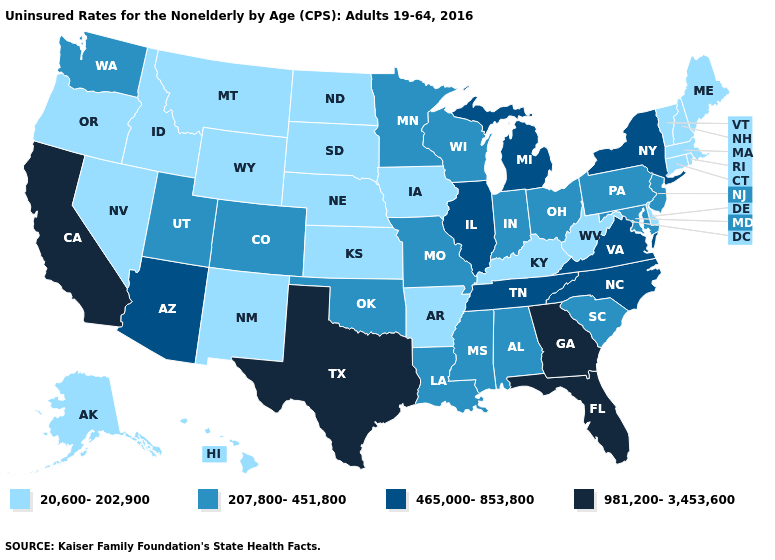Name the states that have a value in the range 981,200-3,453,600?
Concise answer only. California, Florida, Georgia, Texas. What is the highest value in the West ?
Write a very short answer. 981,200-3,453,600. What is the value of Georgia?
Give a very brief answer. 981,200-3,453,600. Does Vermont have the same value as Louisiana?
Quick response, please. No. Name the states that have a value in the range 20,600-202,900?
Keep it brief. Alaska, Arkansas, Connecticut, Delaware, Hawaii, Idaho, Iowa, Kansas, Kentucky, Maine, Massachusetts, Montana, Nebraska, Nevada, New Hampshire, New Mexico, North Dakota, Oregon, Rhode Island, South Dakota, Vermont, West Virginia, Wyoming. Among the states that border Tennessee , which have the highest value?
Be succinct. Georgia. Does Rhode Island have the same value as Connecticut?
Be succinct. Yes. Is the legend a continuous bar?
Be succinct. No. Name the states that have a value in the range 207,800-451,800?
Quick response, please. Alabama, Colorado, Indiana, Louisiana, Maryland, Minnesota, Mississippi, Missouri, New Jersey, Ohio, Oklahoma, Pennsylvania, South Carolina, Utah, Washington, Wisconsin. What is the highest value in the USA?
Be succinct. 981,200-3,453,600. Which states have the lowest value in the MidWest?
Write a very short answer. Iowa, Kansas, Nebraska, North Dakota, South Dakota. Does Rhode Island have the same value as Virginia?
Give a very brief answer. No. 